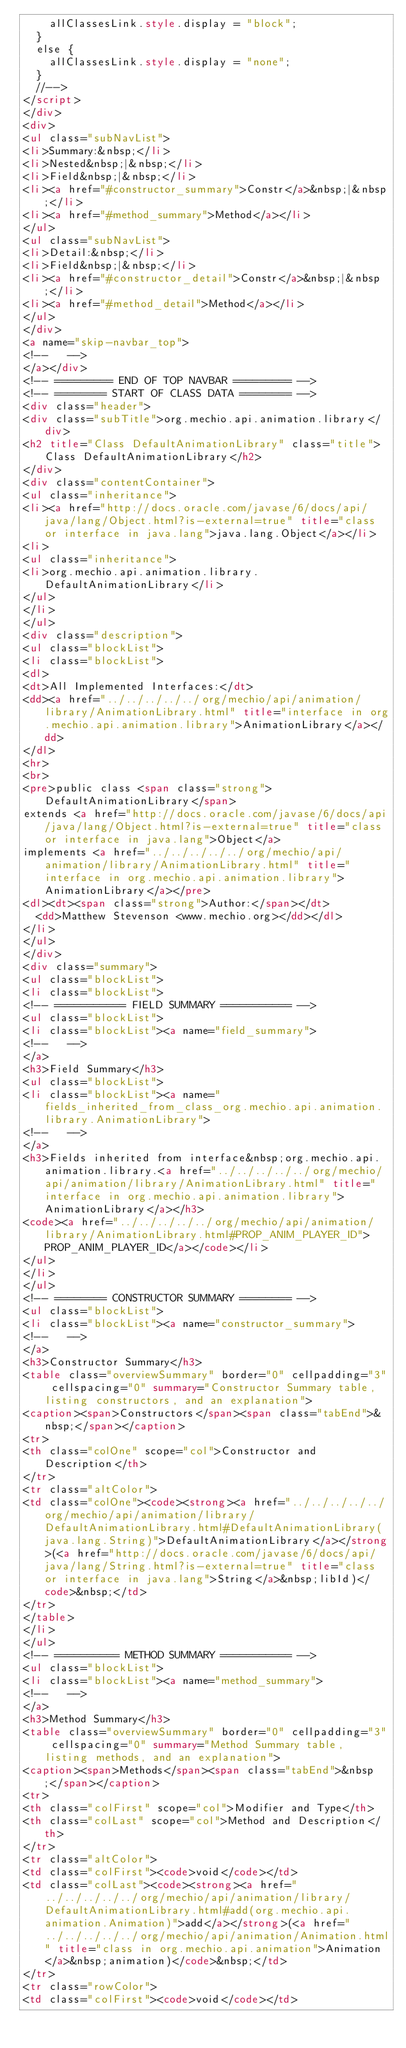<code> <loc_0><loc_0><loc_500><loc_500><_HTML_>    allClassesLink.style.display = "block";
  }
  else {
    allClassesLink.style.display = "none";
  }
  //-->
</script>
</div>
<div>
<ul class="subNavList">
<li>Summary:&nbsp;</li>
<li>Nested&nbsp;|&nbsp;</li>
<li>Field&nbsp;|&nbsp;</li>
<li><a href="#constructor_summary">Constr</a>&nbsp;|&nbsp;</li>
<li><a href="#method_summary">Method</a></li>
</ul>
<ul class="subNavList">
<li>Detail:&nbsp;</li>
<li>Field&nbsp;|&nbsp;</li>
<li><a href="#constructor_detail">Constr</a>&nbsp;|&nbsp;</li>
<li><a href="#method_detail">Method</a></li>
</ul>
</div>
<a name="skip-navbar_top">
<!--   -->
</a></div>
<!-- ========= END OF TOP NAVBAR ========= -->
<!-- ======== START OF CLASS DATA ======== -->
<div class="header">
<div class="subTitle">org.mechio.api.animation.library</div>
<h2 title="Class DefaultAnimationLibrary" class="title">Class DefaultAnimationLibrary</h2>
</div>
<div class="contentContainer">
<ul class="inheritance">
<li><a href="http://docs.oracle.com/javase/6/docs/api/java/lang/Object.html?is-external=true" title="class or interface in java.lang">java.lang.Object</a></li>
<li>
<ul class="inheritance">
<li>org.mechio.api.animation.library.DefaultAnimationLibrary</li>
</ul>
</li>
</ul>
<div class="description">
<ul class="blockList">
<li class="blockList">
<dl>
<dt>All Implemented Interfaces:</dt>
<dd><a href="../../../../../org/mechio/api/animation/library/AnimationLibrary.html" title="interface in org.mechio.api.animation.library">AnimationLibrary</a></dd>
</dl>
<hr>
<br>
<pre>public class <span class="strong">DefaultAnimationLibrary</span>
extends <a href="http://docs.oracle.com/javase/6/docs/api/java/lang/Object.html?is-external=true" title="class or interface in java.lang">Object</a>
implements <a href="../../../../../org/mechio/api/animation/library/AnimationLibrary.html" title="interface in org.mechio.api.animation.library">AnimationLibrary</a></pre>
<dl><dt><span class="strong">Author:</span></dt>
  <dd>Matthew Stevenson <www.mechio.org></dd></dl>
</li>
</ul>
</div>
<div class="summary">
<ul class="blockList">
<li class="blockList">
<!-- =========== FIELD SUMMARY =========== -->
<ul class="blockList">
<li class="blockList"><a name="field_summary">
<!--   -->
</a>
<h3>Field Summary</h3>
<ul class="blockList">
<li class="blockList"><a name="fields_inherited_from_class_org.mechio.api.animation.library.AnimationLibrary">
<!--   -->
</a>
<h3>Fields inherited from interface&nbsp;org.mechio.api.animation.library.<a href="../../../../../org/mechio/api/animation/library/AnimationLibrary.html" title="interface in org.mechio.api.animation.library">AnimationLibrary</a></h3>
<code><a href="../../../../../org/mechio/api/animation/library/AnimationLibrary.html#PROP_ANIM_PLAYER_ID">PROP_ANIM_PLAYER_ID</a></code></li>
</ul>
</li>
</ul>
<!-- ======== CONSTRUCTOR SUMMARY ======== -->
<ul class="blockList">
<li class="blockList"><a name="constructor_summary">
<!--   -->
</a>
<h3>Constructor Summary</h3>
<table class="overviewSummary" border="0" cellpadding="3" cellspacing="0" summary="Constructor Summary table, listing constructors, and an explanation">
<caption><span>Constructors</span><span class="tabEnd">&nbsp;</span></caption>
<tr>
<th class="colOne" scope="col">Constructor and Description</th>
</tr>
<tr class="altColor">
<td class="colOne"><code><strong><a href="../../../../../org/mechio/api/animation/library/DefaultAnimationLibrary.html#DefaultAnimationLibrary(java.lang.String)">DefaultAnimationLibrary</a></strong>(<a href="http://docs.oracle.com/javase/6/docs/api/java/lang/String.html?is-external=true" title="class or interface in java.lang">String</a>&nbsp;libId)</code>&nbsp;</td>
</tr>
</table>
</li>
</ul>
<!-- ========== METHOD SUMMARY =========== -->
<ul class="blockList">
<li class="blockList"><a name="method_summary">
<!--   -->
</a>
<h3>Method Summary</h3>
<table class="overviewSummary" border="0" cellpadding="3" cellspacing="0" summary="Method Summary table, listing methods, and an explanation">
<caption><span>Methods</span><span class="tabEnd">&nbsp;</span></caption>
<tr>
<th class="colFirst" scope="col">Modifier and Type</th>
<th class="colLast" scope="col">Method and Description</th>
</tr>
<tr class="altColor">
<td class="colFirst"><code>void</code></td>
<td class="colLast"><code><strong><a href="../../../../../org/mechio/api/animation/library/DefaultAnimationLibrary.html#add(org.mechio.api.animation.Animation)">add</a></strong>(<a href="../../../../../org/mechio/api/animation/Animation.html" title="class in org.mechio.api.animation">Animation</a>&nbsp;animation)</code>&nbsp;</td>
</tr>
<tr class="rowColor">
<td class="colFirst"><code>void</code></td></code> 